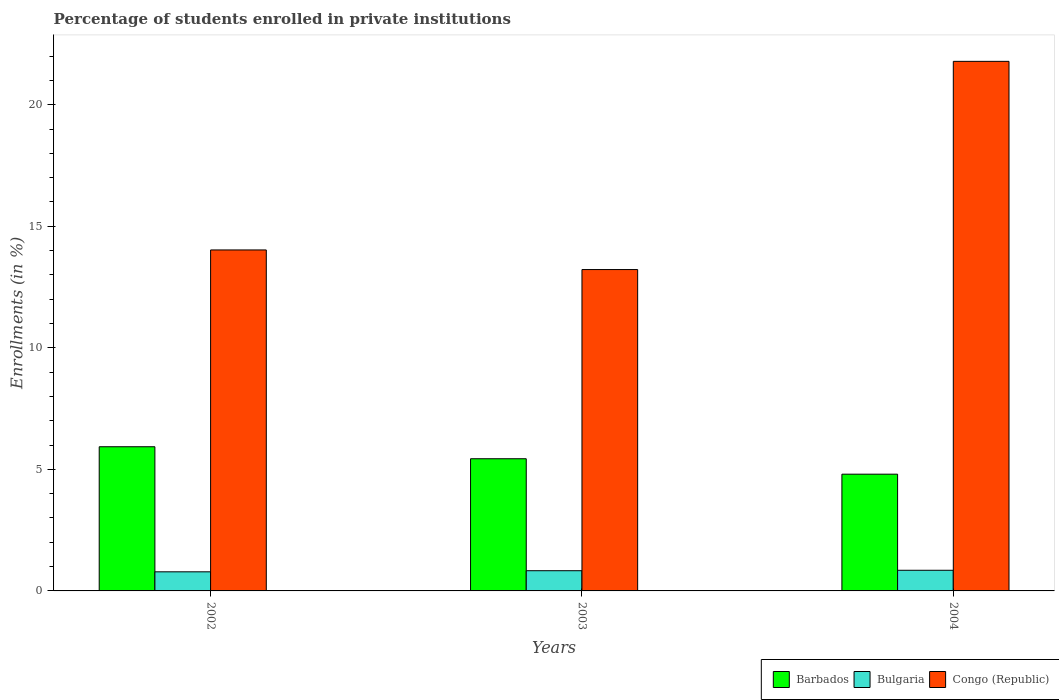How many groups of bars are there?
Your response must be concise. 3. How many bars are there on the 3rd tick from the right?
Your answer should be very brief. 3. What is the label of the 2nd group of bars from the left?
Ensure brevity in your answer.  2003. What is the percentage of trained teachers in Congo (Republic) in 2002?
Keep it short and to the point. 14.03. Across all years, what is the maximum percentage of trained teachers in Bulgaria?
Make the answer very short. 0.85. Across all years, what is the minimum percentage of trained teachers in Barbados?
Ensure brevity in your answer.  4.8. In which year was the percentage of trained teachers in Bulgaria maximum?
Keep it short and to the point. 2004. What is the total percentage of trained teachers in Bulgaria in the graph?
Make the answer very short. 2.47. What is the difference between the percentage of trained teachers in Barbados in 2003 and that in 2004?
Your answer should be very brief. 0.63. What is the difference between the percentage of trained teachers in Barbados in 2003 and the percentage of trained teachers in Bulgaria in 2002?
Make the answer very short. 4.65. What is the average percentage of trained teachers in Barbados per year?
Keep it short and to the point. 5.39. In the year 2002, what is the difference between the percentage of trained teachers in Bulgaria and percentage of trained teachers in Barbados?
Make the answer very short. -5.15. What is the ratio of the percentage of trained teachers in Barbados in 2002 to that in 2004?
Keep it short and to the point. 1.23. What is the difference between the highest and the second highest percentage of trained teachers in Congo (Republic)?
Make the answer very short. 7.76. What is the difference between the highest and the lowest percentage of trained teachers in Bulgaria?
Keep it short and to the point. 0.06. Is the sum of the percentage of trained teachers in Barbados in 2003 and 2004 greater than the maximum percentage of trained teachers in Bulgaria across all years?
Offer a very short reply. Yes. What does the 3rd bar from the left in 2003 represents?
Provide a succinct answer. Congo (Republic). Is it the case that in every year, the sum of the percentage of trained teachers in Bulgaria and percentage of trained teachers in Barbados is greater than the percentage of trained teachers in Congo (Republic)?
Your answer should be very brief. No. How many bars are there?
Make the answer very short. 9. Does the graph contain grids?
Ensure brevity in your answer.  No. How are the legend labels stacked?
Offer a very short reply. Horizontal. What is the title of the graph?
Give a very brief answer. Percentage of students enrolled in private institutions. What is the label or title of the X-axis?
Provide a succinct answer. Years. What is the label or title of the Y-axis?
Your answer should be very brief. Enrollments (in %). What is the Enrollments (in %) in Barbados in 2002?
Your answer should be compact. 5.93. What is the Enrollments (in %) in Bulgaria in 2002?
Provide a short and direct response. 0.79. What is the Enrollments (in %) in Congo (Republic) in 2002?
Provide a succinct answer. 14.03. What is the Enrollments (in %) of Barbados in 2003?
Provide a short and direct response. 5.44. What is the Enrollments (in %) of Bulgaria in 2003?
Keep it short and to the point. 0.83. What is the Enrollments (in %) in Congo (Republic) in 2003?
Your response must be concise. 13.22. What is the Enrollments (in %) of Barbados in 2004?
Your response must be concise. 4.8. What is the Enrollments (in %) in Bulgaria in 2004?
Make the answer very short. 0.85. What is the Enrollments (in %) of Congo (Republic) in 2004?
Give a very brief answer. 21.79. Across all years, what is the maximum Enrollments (in %) in Barbados?
Your response must be concise. 5.93. Across all years, what is the maximum Enrollments (in %) of Bulgaria?
Your response must be concise. 0.85. Across all years, what is the maximum Enrollments (in %) of Congo (Republic)?
Ensure brevity in your answer.  21.79. Across all years, what is the minimum Enrollments (in %) of Barbados?
Provide a short and direct response. 4.8. Across all years, what is the minimum Enrollments (in %) of Bulgaria?
Your answer should be very brief. 0.79. Across all years, what is the minimum Enrollments (in %) in Congo (Republic)?
Offer a terse response. 13.22. What is the total Enrollments (in %) of Barbados in the graph?
Your response must be concise. 16.17. What is the total Enrollments (in %) in Bulgaria in the graph?
Your response must be concise. 2.47. What is the total Enrollments (in %) of Congo (Republic) in the graph?
Keep it short and to the point. 49.03. What is the difference between the Enrollments (in %) of Barbados in 2002 and that in 2003?
Give a very brief answer. 0.49. What is the difference between the Enrollments (in %) of Bulgaria in 2002 and that in 2003?
Offer a terse response. -0.05. What is the difference between the Enrollments (in %) of Congo (Republic) in 2002 and that in 2003?
Your response must be concise. 0.81. What is the difference between the Enrollments (in %) of Barbados in 2002 and that in 2004?
Offer a very short reply. 1.13. What is the difference between the Enrollments (in %) of Bulgaria in 2002 and that in 2004?
Keep it short and to the point. -0.06. What is the difference between the Enrollments (in %) in Congo (Republic) in 2002 and that in 2004?
Your answer should be very brief. -7.76. What is the difference between the Enrollments (in %) of Barbados in 2003 and that in 2004?
Give a very brief answer. 0.63. What is the difference between the Enrollments (in %) in Bulgaria in 2003 and that in 2004?
Offer a very short reply. -0.02. What is the difference between the Enrollments (in %) in Congo (Republic) in 2003 and that in 2004?
Your response must be concise. -8.57. What is the difference between the Enrollments (in %) in Barbados in 2002 and the Enrollments (in %) in Bulgaria in 2003?
Your response must be concise. 5.1. What is the difference between the Enrollments (in %) in Barbados in 2002 and the Enrollments (in %) in Congo (Republic) in 2003?
Ensure brevity in your answer.  -7.29. What is the difference between the Enrollments (in %) in Bulgaria in 2002 and the Enrollments (in %) in Congo (Republic) in 2003?
Your response must be concise. -12.44. What is the difference between the Enrollments (in %) in Barbados in 2002 and the Enrollments (in %) in Bulgaria in 2004?
Offer a very short reply. 5.08. What is the difference between the Enrollments (in %) of Barbados in 2002 and the Enrollments (in %) of Congo (Republic) in 2004?
Provide a succinct answer. -15.85. What is the difference between the Enrollments (in %) in Bulgaria in 2002 and the Enrollments (in %) in Congo (Republic) in 2004?
Make the answer very short. -21. What is the difference between the Enrollments (in %) in Barbados in 2003 and the Enrollments (in %) in Bulgaria in 2004?
Provide a succinct answer. 4.59. What is the difference between the Enrollments (in %) of Barbados in 2003 and the Enrollments (in %) of Congo (Republic) in 2004?
Offer a very short reply. -16.35. What is the difference between the Enrollments (in %) in Bulgaria in 2003 and the Enrollments (in %) in Congo (Republic) in 2004?
Your answer should be compact. -20.95. What is the average Enrollments (in %) in Barbados per year?
Your response must be concise. 5.39. What is the average Enrollments (in %) in Bulgaria per year?
Your answer should be very brief. 0.82. What is the average Enrollments (in %) in Congo (Republic) per year?
Keep it short and to the point. 16.34. In the year 2002, what is the difference between the Enrollments (in %) in Barbados and Enrollments (in %) in Bulgaria?
Your response must be concise. 5.15. In the year 2002, what is the difference between the Enrollments (in %) of Barbados and Enrollments (in %) of Congo (Republic)?
Your answer should be very brief. -8.1. In the year 2002, what is the difference between the Enrollments (in %) of Bulgaria and Enrollments (in %) of Congo (Republic)?
Your response must be concise. -13.24. In the year 2003, what is the difference between the Enrollments (in %) of Barbados and Enrollments (in %) of Bulgaria?
Your answer should be very brief. 4.61. In the year 2003, what is the difference between the Enrollments (in %) in Barbados and Enrollments (in %) in Congo (Republic)?
Offer a very short reply. -7.78. In the year 2003, what is the difference between the Enrollments (in %) in Bulgaria and Enrollments (in %) in Congo (Republic)?
Ensure brevity in your answer.  -12.39. In the year 2004, what is the difference between the Enrollments (in %) of Barbados and Enrollments (in %) of Bulgaria?
Your response must be concise. 3.95. In the year 2004, what is the difference between the Enrollments (in %) in Barbados and Enrollments (in %) in Congo (Republic)?
Your answer should be compact. -16.98. In the year 2004, what is the difference between the Enrollments (in %) of Bulgaria and Enrollments (in %) of Congo (Republic)?
Offer a very short reply. -20.94. What is the ratio of the Enrollments (in %) in Barbados in 2002 to that in 2003?
Your answer should be compact. 1.09. What is the ratio of the Enrollments (in %) in Bulgaria in 2002 to that in 2003?
Your answer should be compact. 0.95. What is the ratio of the Enrollments (in %) in Congo (Republic) in 2002 to that in 2003?
Your answer should be very brief. 1.06. What is the ratio of the Enrollments (in %) of Barbados in 2002 to that in 2004?
Provide a short and direct response. 1.24. What is the ratio of the Enrollments (in %) of Bulgaria in 2002 to that in 2004?
Your answer should be very brief. 0.92. What is the ratio of the Enrollments (in %) of Congo (Republic) in 2002 to that in 2004?
Your response must be concise. 0.64. What is the ratio of the Enrollments (in %) of Barbados in 2003 to that in 2004?
Give a very brief answer. 1.13. What is the ratio of the Enrollments (in %) in Bulgaria in 2003 to that in 2004?
Your answer should be very brief. 0.98. What is the ratio of the Enrollments (in %) of Congo (Republic) in 2003 to that in 2004?
Keep it short and to the point. 0.61. What is the difference between the highest and the second highest Enrollments (in %) of Barbados?
Offer a very short reply. 0.49. What is the difference between the highest and the second highest Enrollments (in %) in Bulgaria?
Offer a very short reply. 0.02. What is the difference between the highest and the second highest Enrollments (in %) of Congo (Republic)?
Ensure brevity in your answer.  7.76. What is the difference between the highest and the lowest Enrollments (in %) of Barbados?
Give a very brief answer. 1.13. What is the difference between the highest and the lowest Enrollments (in %) in Bulgaria?
Keep it short and to the point. 0.06. What is the difference between the highest and the lowest Enrollments (in %) in Congo (Republic)?
Provide a succinct answer. 8.57. 